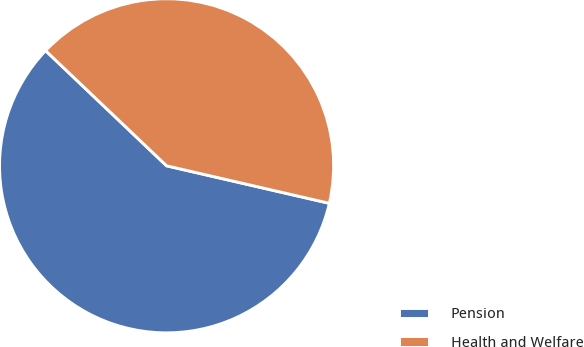Convert chart. <chart><loc_0><loc_0><loc_500><loc_500><pie_chart><fcel>Pension<fcel>Health and Welfare<nl><fcel>58.5%<fcel>41.5%<nl></chart> 